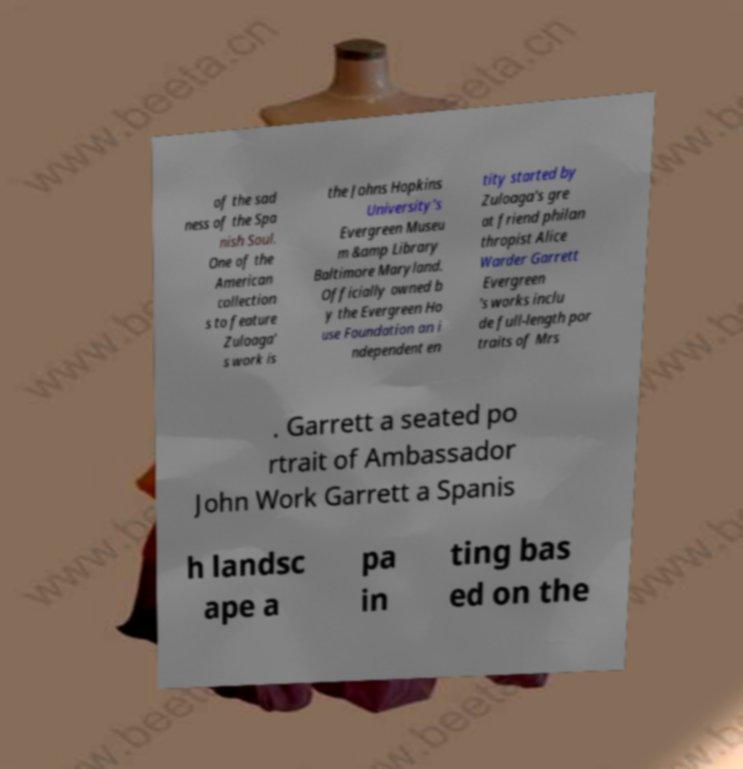Could you extract and type out the text from this image? of the sad ness of the Spa nish Soul. One of the American collection s to feature Zuloaga' s work is the Johns Hopkins University's Evergreen Museu m &amp Library Baltimore Maryland. Officially owned b y the Evergreen Ho use Foundation an i ndependent en tity started by Zuloaga's gre at friend philan thropist Alice Warder Garrett Evergreen 's works inclu de full-length por traits of Mrs . Garrett a seated po rtrait of Ambassador John Work Garrett a Spanis h landsc ape a pa in ting bas ed on the 